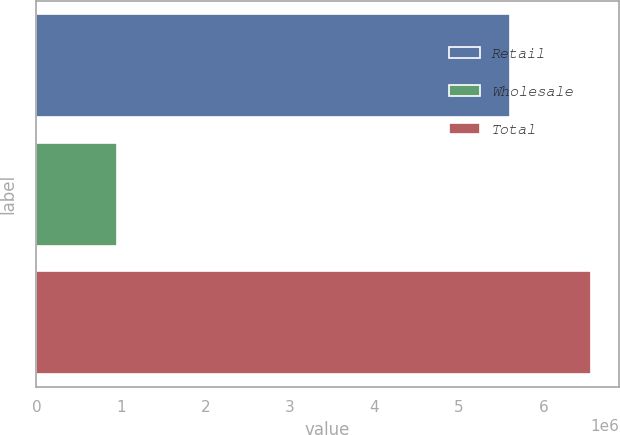Convert chart. <chart><loc_0><loc_0><loc_500><loc_500><bar_chart><fcel>Retail<fcel>Wholesale<fcel>Total<nl><fcel>5.60792e+06<fcel>952321<fcel>6.56024e+06<nl></chart> 